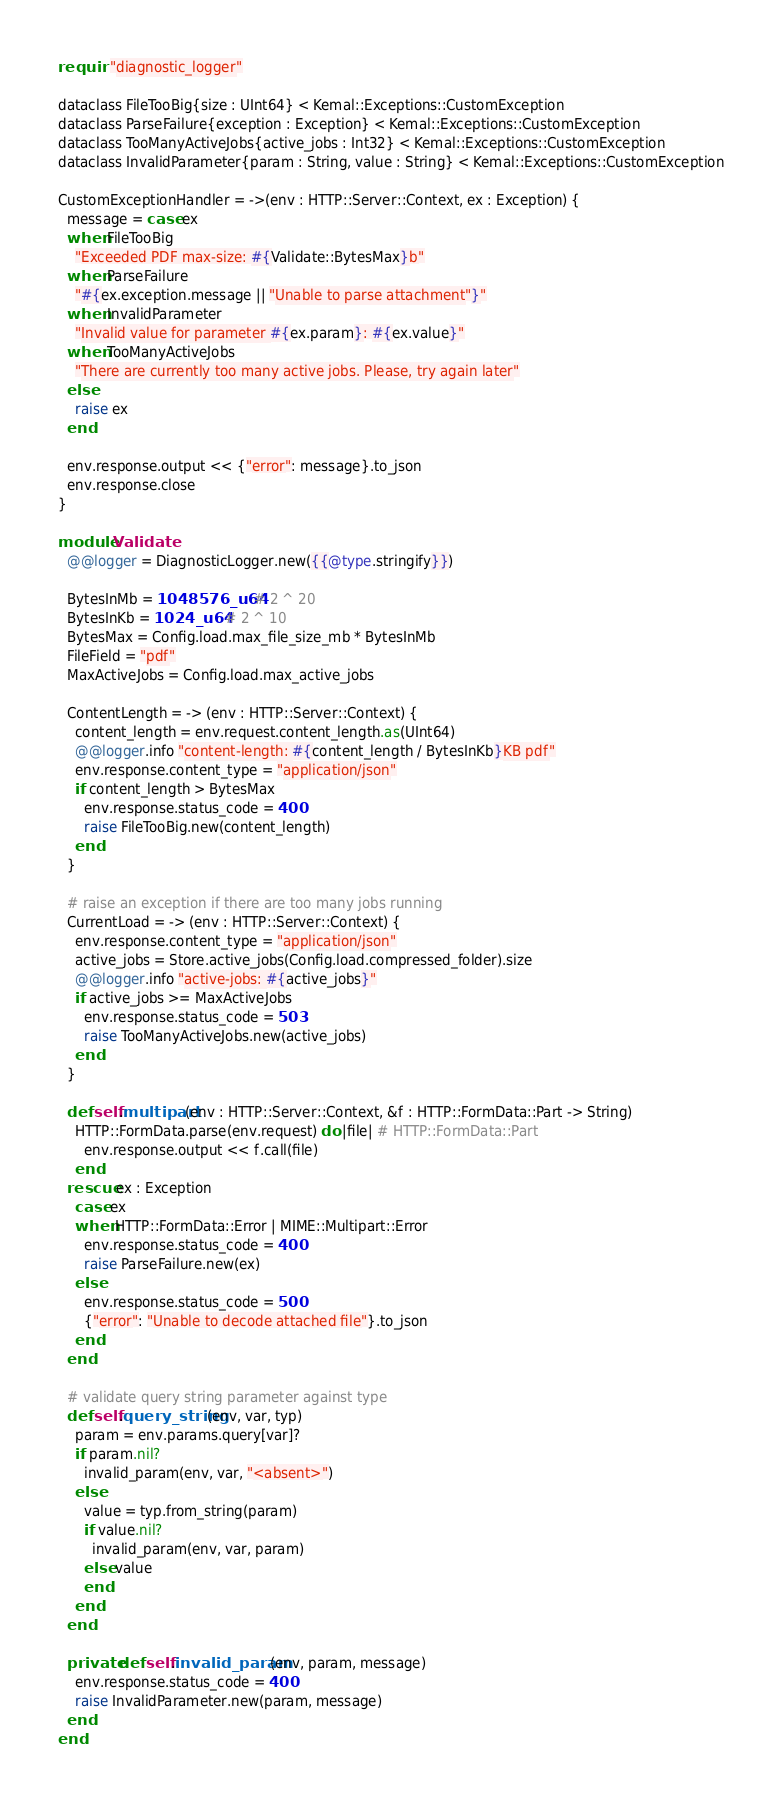Convert code to text. <code><loc_0><loc_0><loc_500><loc_500><_Crystal_>require "diagnostic_logger"

dataclass FileTooBig{size : UInt64} < Kemal::Exceptions::CustomException
dataclass ParseFailure{exception : Exception} < Kemal::Exceptions::CustomException
dataclass TooManyActiveJobs{active_jobs : Int32} < Kemal::Exceptions::CustomException
dataclass InvalidParameter{param : String, value : String} < Kemal::Exceptions::CustomException

CustomExceptionHandler = ->(env : HTTP::Server::Context, ex : Exception) {
  message = case ex
  when FileTooBig
    "Exceeded PDF max-size: #{Validate::BytesMax}b"
  when ParseFailure
    "#{ex.exception.message || "Unable to parse attachment"}"
  when InvalidParameter
    "Invalid value for parameter #{ex.param}: #{ex.value}"
  when TooManyActiveJobs
    "There are currently too many active jobs. Please, try again later"
  else
    raise ex
  end
  
  env.response.output << {"error": message}.to_json
  env.response.close
}

module Validate
  @@logger = DiagnosticLogger.new({{@type.stringify}})

  BytesInMb = 1048576_u64 # 2 ^ 20
  BytesInKb = 1024_u64 # 2 ^ 10
  BytesMax = Config.load.max_file_size_mb * BytesInMb
  FileField = "pdf"
  MaxActiveJobs = Config.load.max_active_jobs

  ContentLength = -> (env : HTTP::Server::Context) {
    content_length = env.request.content_length.as(UInt64)
    @@logger.info "content-length: #{content_length / BytesInKb}KB pdf"
    env.response.content_type = "application/json"
    if content_length > BytesMax
      env.response.status_code = 400
      raise FileTooBig.new(content_length)
    end
  }

  # raise an exception if there are too many jobs running
  CurrentLoad = -> (env : HTTP::Server::Context) {
    env.response.content_type = "application/json"
    active_jobs = Store.active_jobs(Config.load.compressed_folder).size
    @@logger.info "active-jobs: #{active_jobs}"
    if active_jobs >= MaxActiveJobs
      env.response.status_code = 503
      raise TooManyActiveJobs.new(active_jobs)
    end
  }

  def self.multipart(env : HTTP::Server::Context, &f : HTTP::FormData::Part -> String)
    HTTP::FormData.parse(env.request) do |file| # HTTP::FormData::Part
      env.response.output << f.call(file)
    end
  rescue ex : Exception
    case ex
    when HTTP::FormData::Error | MIME::Multipart::Error
      env.response.status_code = 400
      raise ParseFailure.new(ex)
    else
      env.response.status_code = 500
      {"error": "Unable to decode attached file"}.to_json
    end
  end

  # validate query string parameter against type
  def self.query_string(env, var, typ)
    param = env.params.query[var]?
    if param.nil?
      invalid_param(env, var, "<absent>")
    else
      value = typ.from_string(param)
      if value.nil?
        invalid_param(env, var, param)
      else value
      end
    end
  end

  private def self.invalid_param(env, param, message)
    env.response.status_code = 400
    raise InvalidParameter.new(param, message)
  end
end
</code> 